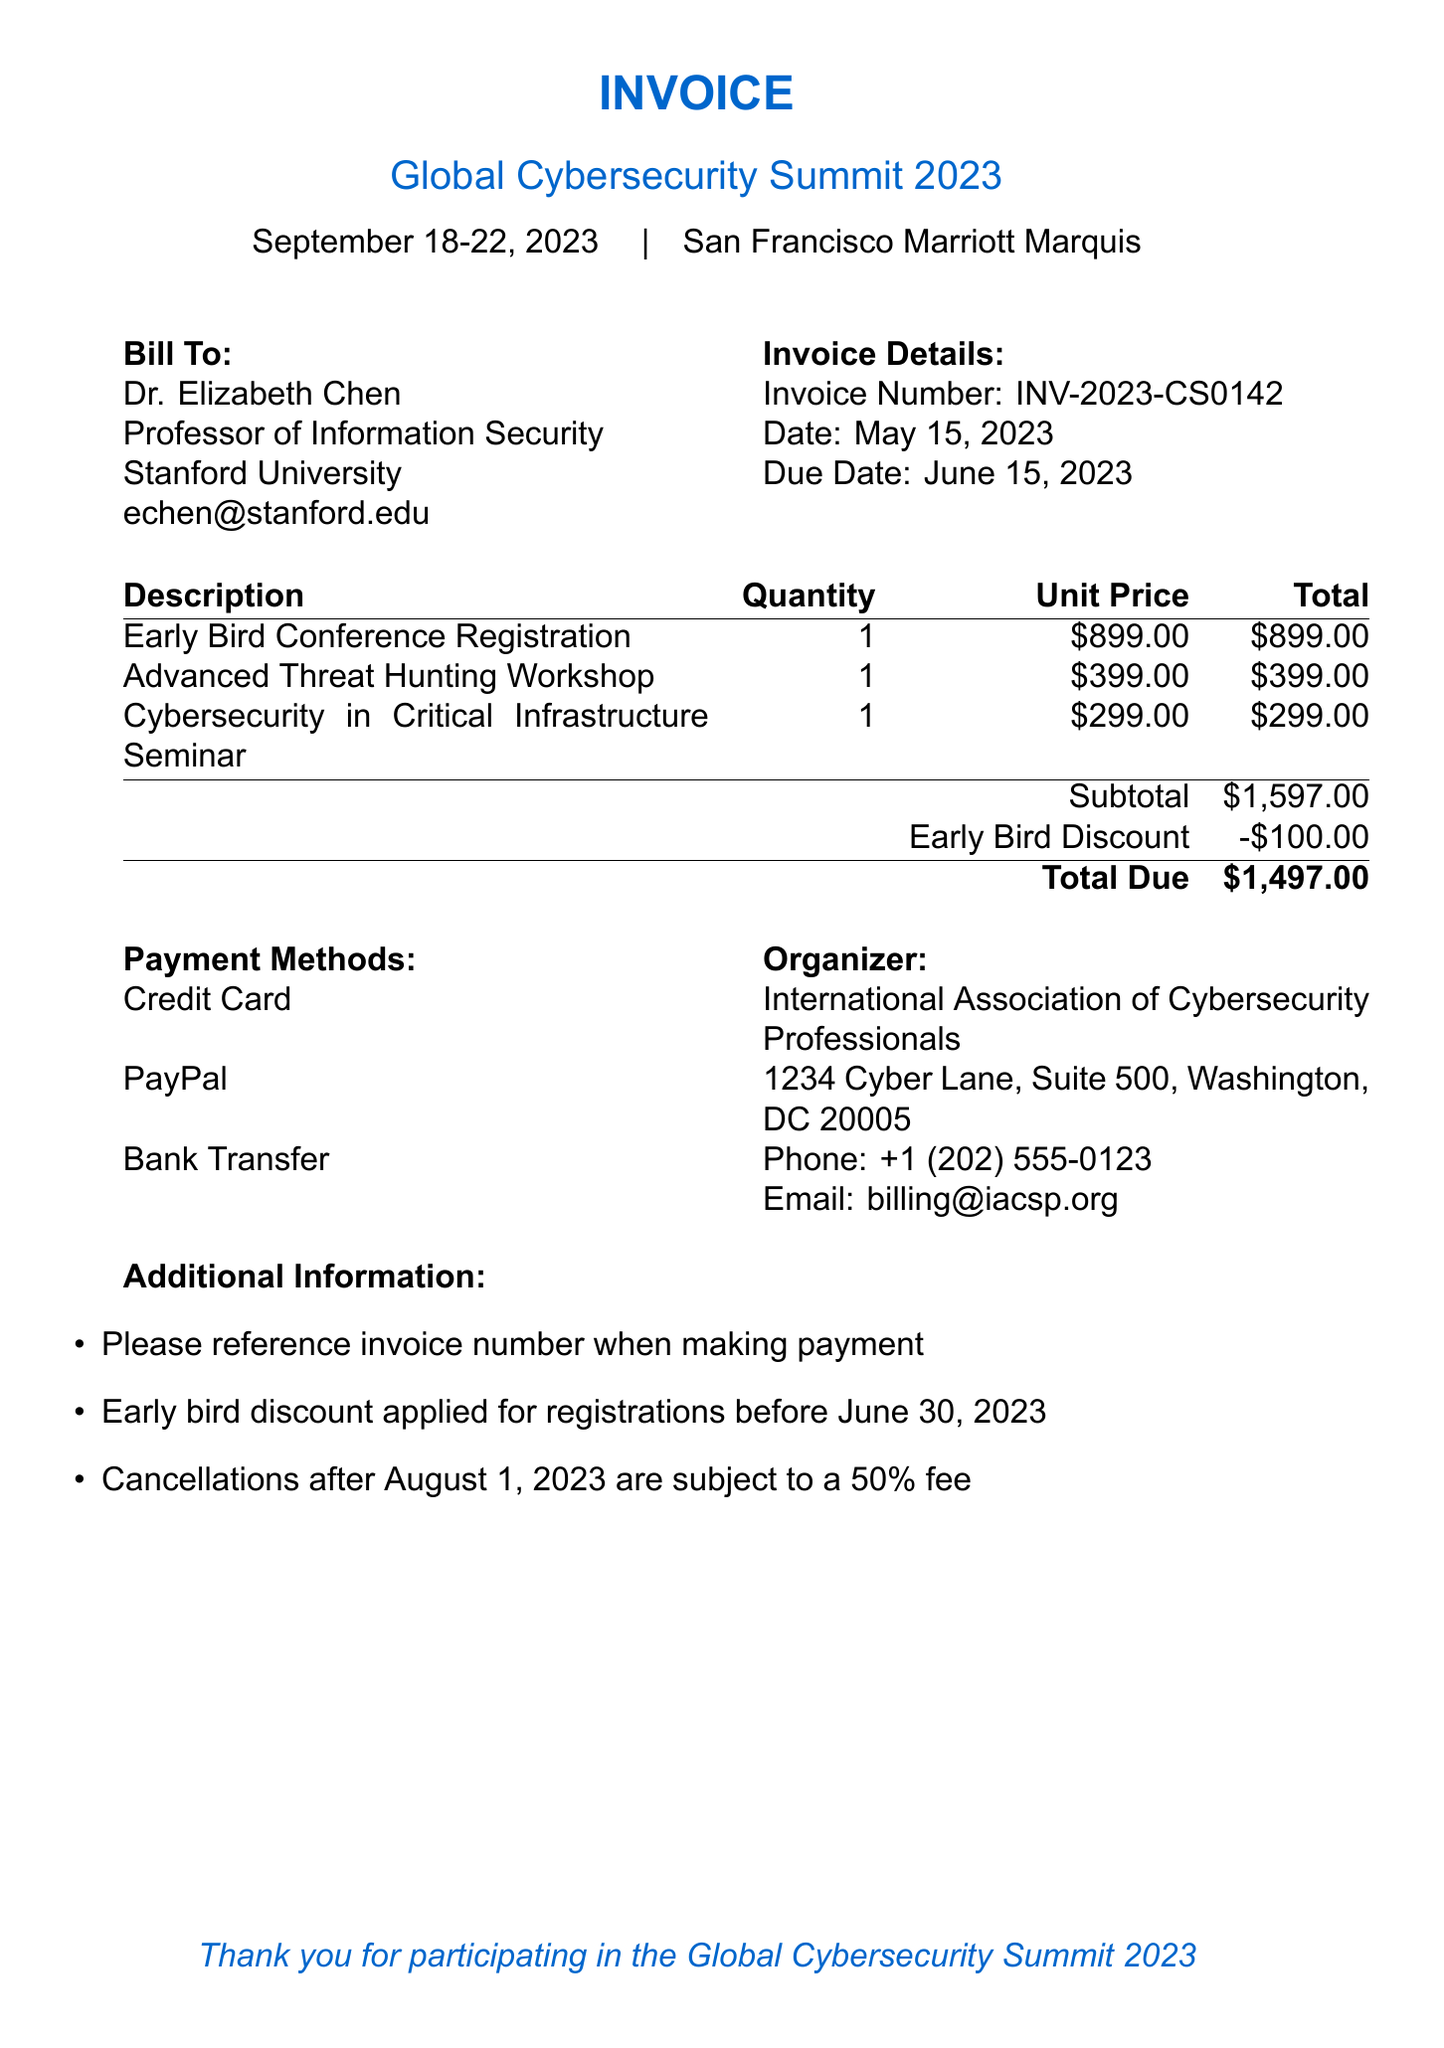What is the invoice number? The invoice number is specified in the document as a unique identifier for this transaction.
Answer: INV-2023-CS0142 What is the due date for the invoice? The due date is provided in the document to indicate when payment must be made.
Answer: June 15, 2023 Who is the attendee for the conference? The attendee's name and title are mentioned in the document, indicating whom the invoice is billed to.
Answer: Dr. Elizabeth Chen What is the total amount due after the early bird discount? The total due is calculated from the subtotal after applying the early bird discount.
Answer: $1497.00 What is the unit price for the Advanced Threat Hunting Workshop? The document lists the cost for this specific workshop, which is clearly stated.
Answer: $399.00 How much is the early bird discount? The amount of discount applied to the invoice to encourage early registration is included in the document.
Answer: -$100.00 What is the venue for the Global Cybersecurity Summit 2023? The venue is specified in the document to indicate where the conference will take place.
Answer: San Francisco Marriott Marquis What is the cancellation fee policy after August 1, 2023? The document includes specific terms regarding cancellations, indicating applicable fees after a certain date.
Answer: 50% fee How many payment methods are listed in the invoice? The number of payment methods is enumerated in the document for attending individuals.
Answer: 3 